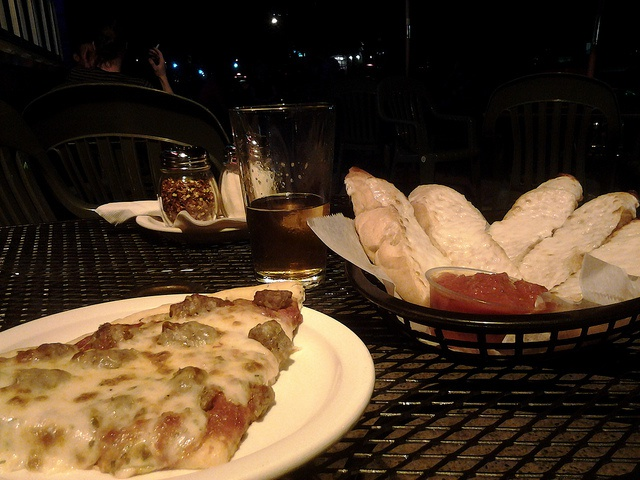Describe the objects in this image and their specific colors. I can see dining table in black, tan, and olive tones, pizza in black, tan, olive, and maroon tones, chair in black, olive, and gray tones, cup in black, maroon, and olive tones, and chair in black, tan, maroon, and olive tones in this image. 